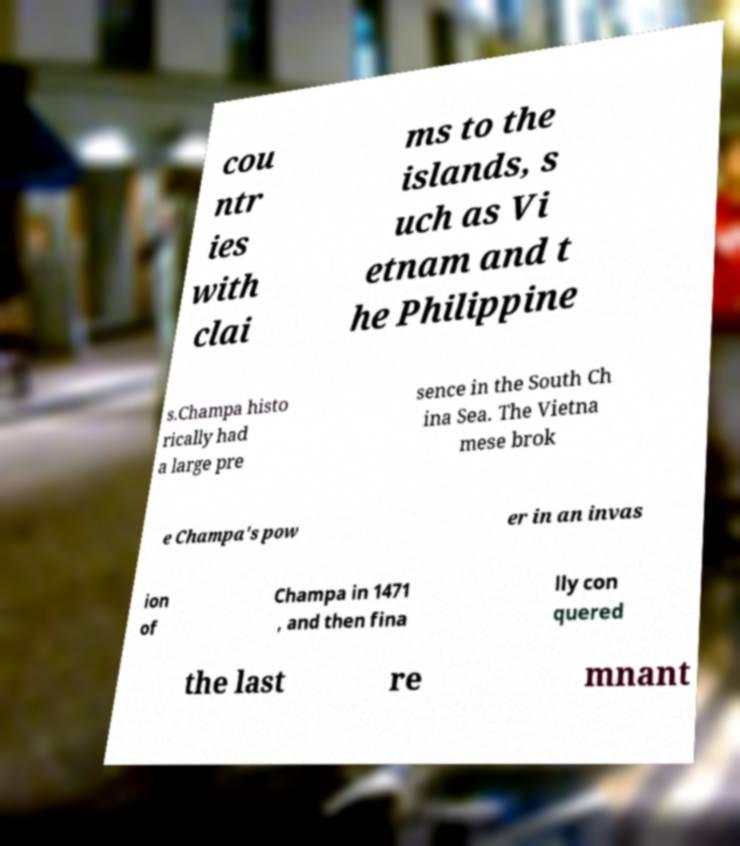Could you assist in decoding the text presented in this image and type it out clearly? cou ntr ies with clai ms to the islands, s uch as Vi etnam and t he Philippine s.Champa histo rically had a large pre sence in the South Ch ina Sea. The Vietna mese brok e Champa's pow er in an invas ion of Champa in 1471 , and then fina lly con quered the last re mnant 